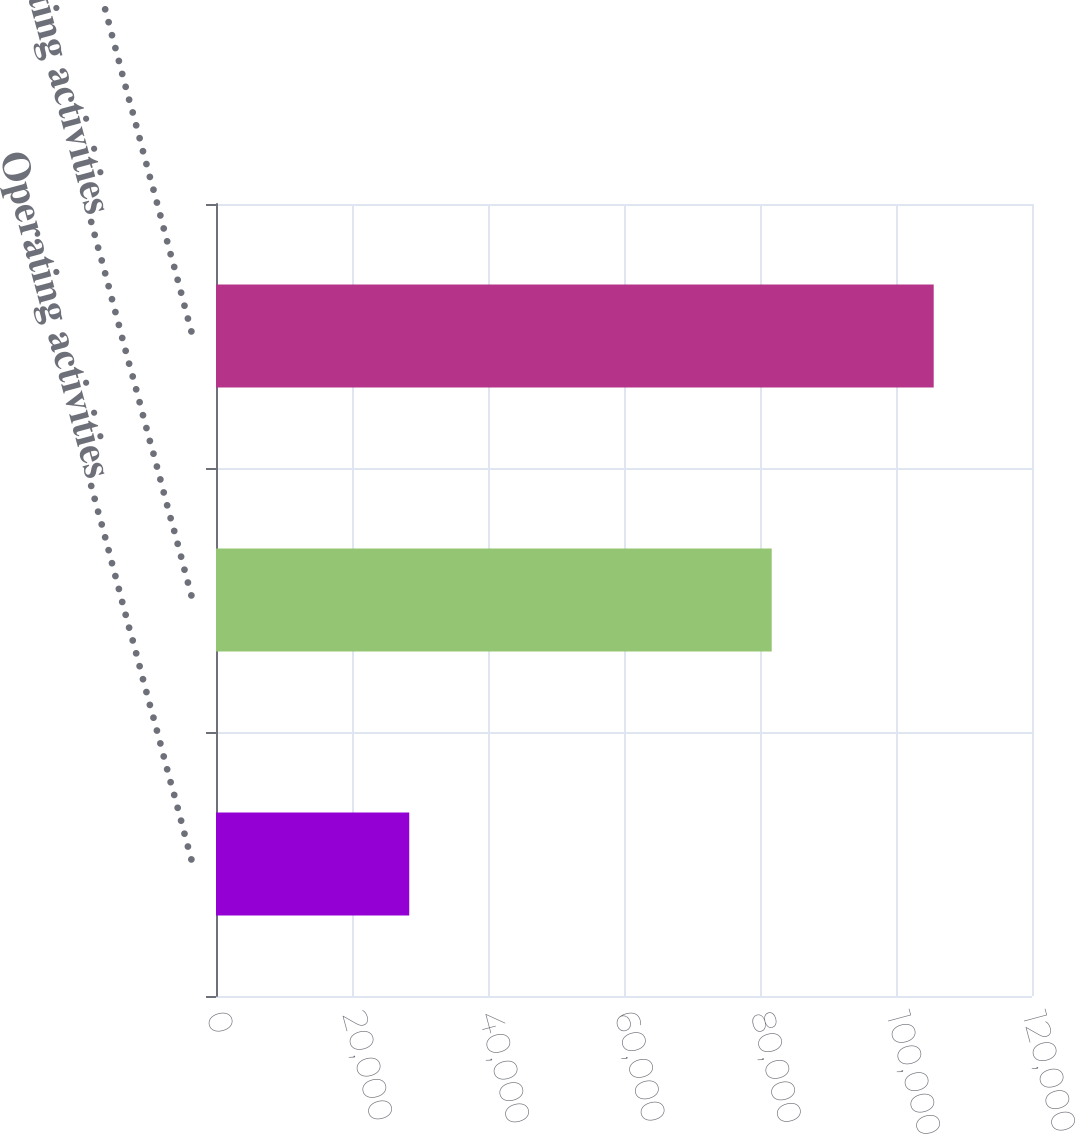Convert chart. <chart><loc_0><loc_0><loc_500><loc_500><bar_chart><fcel>Operating activities…………………………<fcel>Investing activities…………………………<fcel>Financing activities…………………………<nl><fcel>28419<fcel>81723<fcel>105544<nl></chart> 